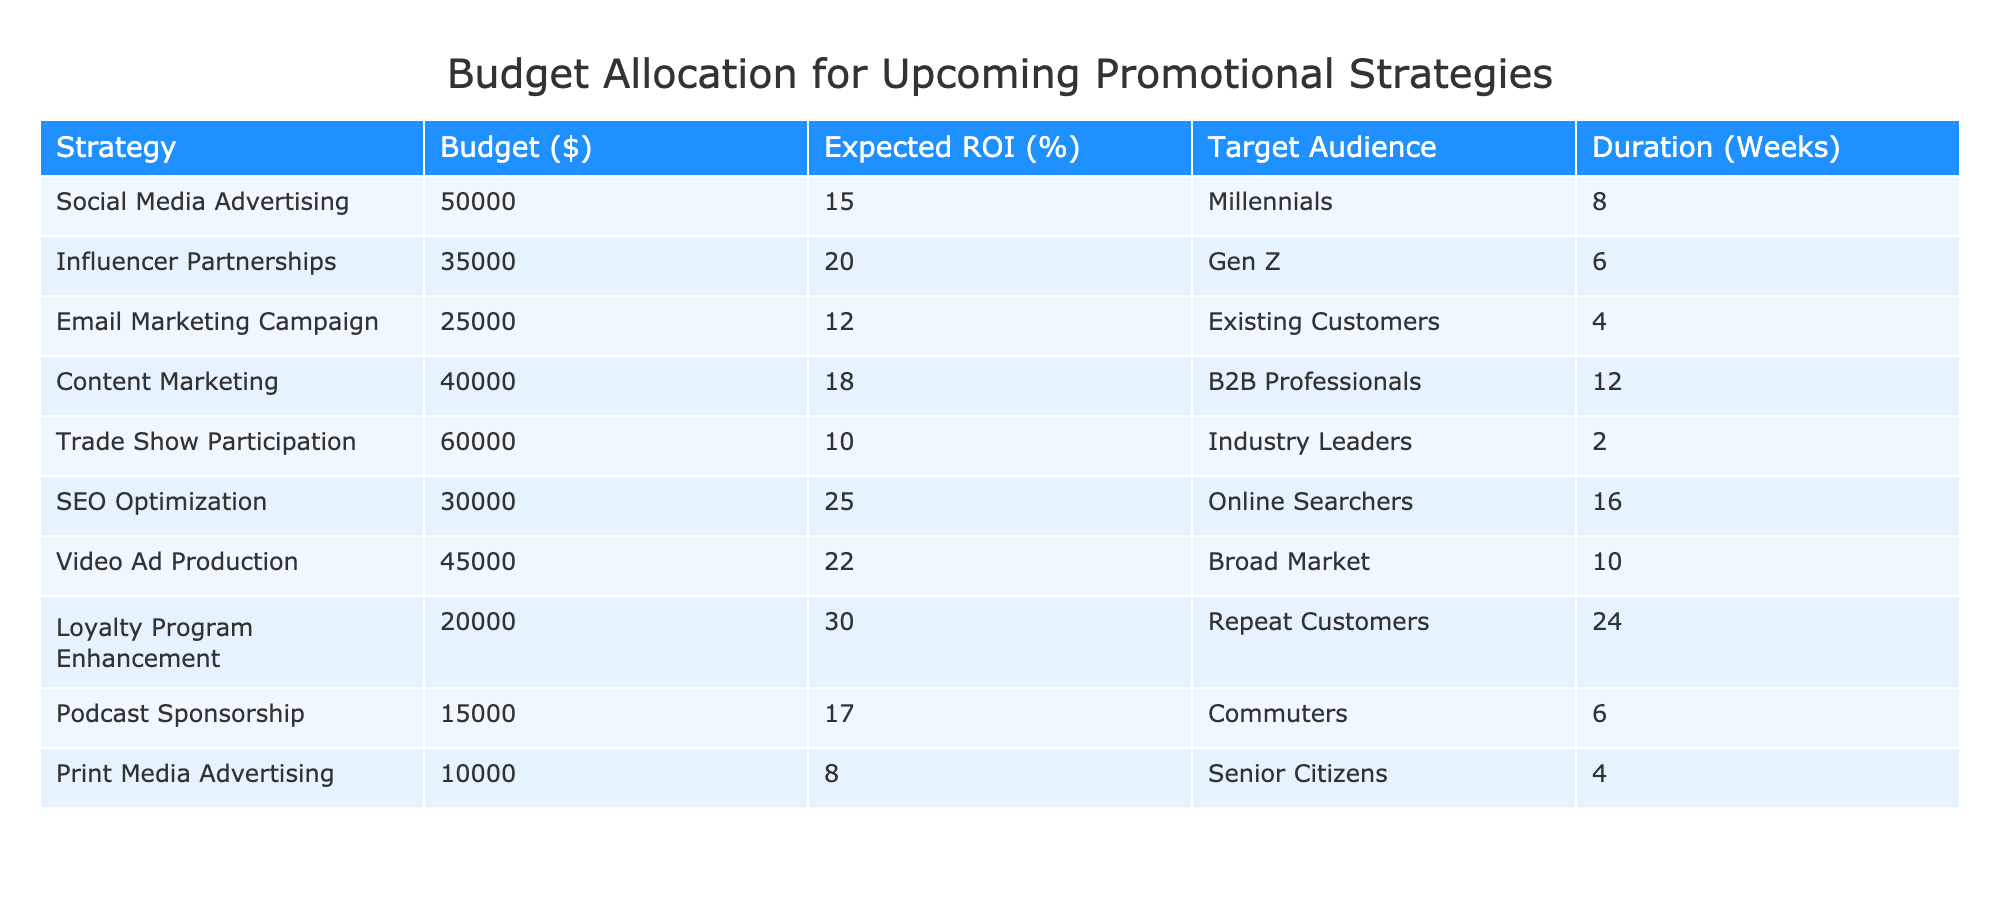What is the highest budget allocated among the strategies? The budgets for each strategy are listed in the "Budget ($)" column. By scanning the values, the highest budget is identified as $60,000 allocated for Trade Show Participation.
Answer: 60000 Which strategy has the lowest expected ROI? By checking the "Expected ROI (%)" column, the lowest value is found to be 8%, which corresponds to the Print Media Advertising strategy.
Answer: 8 What is the total budget allocated for social media related strategies (Social Media Advertising and Influencer Partnerships)? The budgets for Social Media Advertising ($50,000) and Influencer Partnerships ($35,000) are added together: 50000 + 35000 = 85000.
Answer: 85000 Do Email Marketing Campaign and Print Media Advertising target the same audience? The "Target Audience" for Email Marketing Campaign is "Existing Customers" and for Print Media Advertising is "Senior Citizens." Since these are different, the answer is no.
Answer: No What is the average expected ROI for the listed strategies? First, the expected ROI percentages for all strategies are summed: 15 + 20 + 12 + 18 + 10 + 25 + 22 + 30 + 17 + 8 =  157. There are 10 strategies in total, so the average is 157 / 10 = 15.7.
Answer: 15.7 Which strategy has the highest expected ROI and which audience does it target? By reviewing the "Expected ROI (%)" column, the highest value is 30%, attributed to the Loyalty Program Enhancement strategy which targets Repeat Customers.
Answer: Loyalty Program Enhancement, Repeat Customers Is the duration for SEO Optimization longer than that of Video Ad Production? The "Duration (Weeks)" for SEO Optimization is 16 weeks, and for Video Ad Production, it is 10 weeks. Since 16 is greater than 10, the answer is yes.
Answer: Yes What is the difference in budget between the Email Marketing Campaign and Trade Show Participation? The budget for Email Marketing Campaign is $25,000, and for Trade Show Participation is $60,000. The difference is calculated as 60000 - 25000 = 35000.
Answer: 35000 How many strategies target a demographic of Millennials or Gen Z? Social Media Advertising targets Millennials, and Influencer Partnerships target Gen Z, totaling 2 strategies that target these demographics.
Answer: 2 